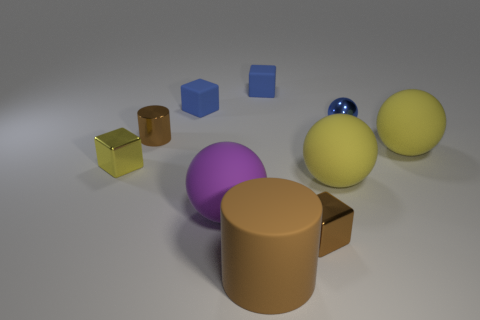What number of things are either big yellow spheres or tiny brown blocks?
Keep it short and to the point. 3. Do the shiny sphere and the sphere to the right of the small blue metal ball have the same size?
Make the answer very short. No. The metallic thing that is on the left side of the cylinder behind the tiny thing left of the small cylinder is what color?
Offer a terse response. Yellow. The rubber cylinder has what color?
Provide a succinct answer. Brown. Are there more yellow spheres that are in front of the large brown matte cylinder than tiny balls on the left side of the tiny brown metallic cylinder?
Offer a terse response. No. There is a large brown matte object; is its shape the same as the brown thing left of the large matte cylinder?
Your response must be concise. Yes. There is a brown thing behind the brown block; is it the same size as the blue rubber block on the left side of the purple matte ball?
Keep it short and to the point. Yes. There is a yellow thing that is to the left of the small object that is in front of the small yellow metal object; is there a metal object behind it?
Ensure brevity in your answer.  Yes. Is the number of small blue metallic objects that are on the left side of the tiny blue ball less than the number of big yellow spheres that are in front of the yellow metallic object?
Provide a succinct answer. Yes. The blue thing that is the same material as the tiny yellow block is what shape?
Offer a very short reply. Sphere. 